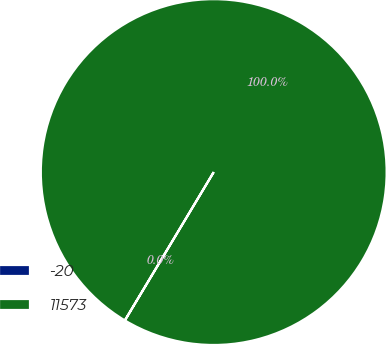Convert chart. <chart><loc_0><loc_0><loc_500><loc_500><pie_chart><fcel>-20<fcel>11573<nl><fcel>0.02%<fcel>99.98%<nl></chart> 